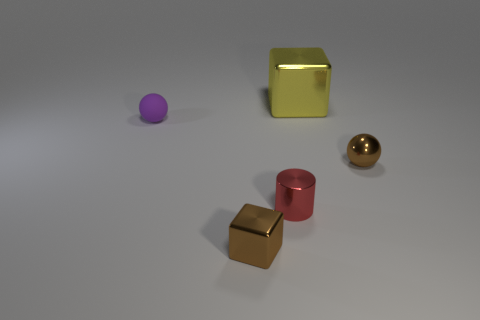Add 4 tiny balls. How many objects exist? 9 Add 2 tiny gray metallic blocks. How many tiny gray metallic blocks exist? 2 Subtract 0 cyan cylinders. How many objects are left? 5 Subtract all cylinders. How many objects are left? 4 Subtract all small shiny cubes. Subtract all large gray rubber blocks. How many objects are left? 4 Add 4 matte balls. How many matte balls are left? 5 